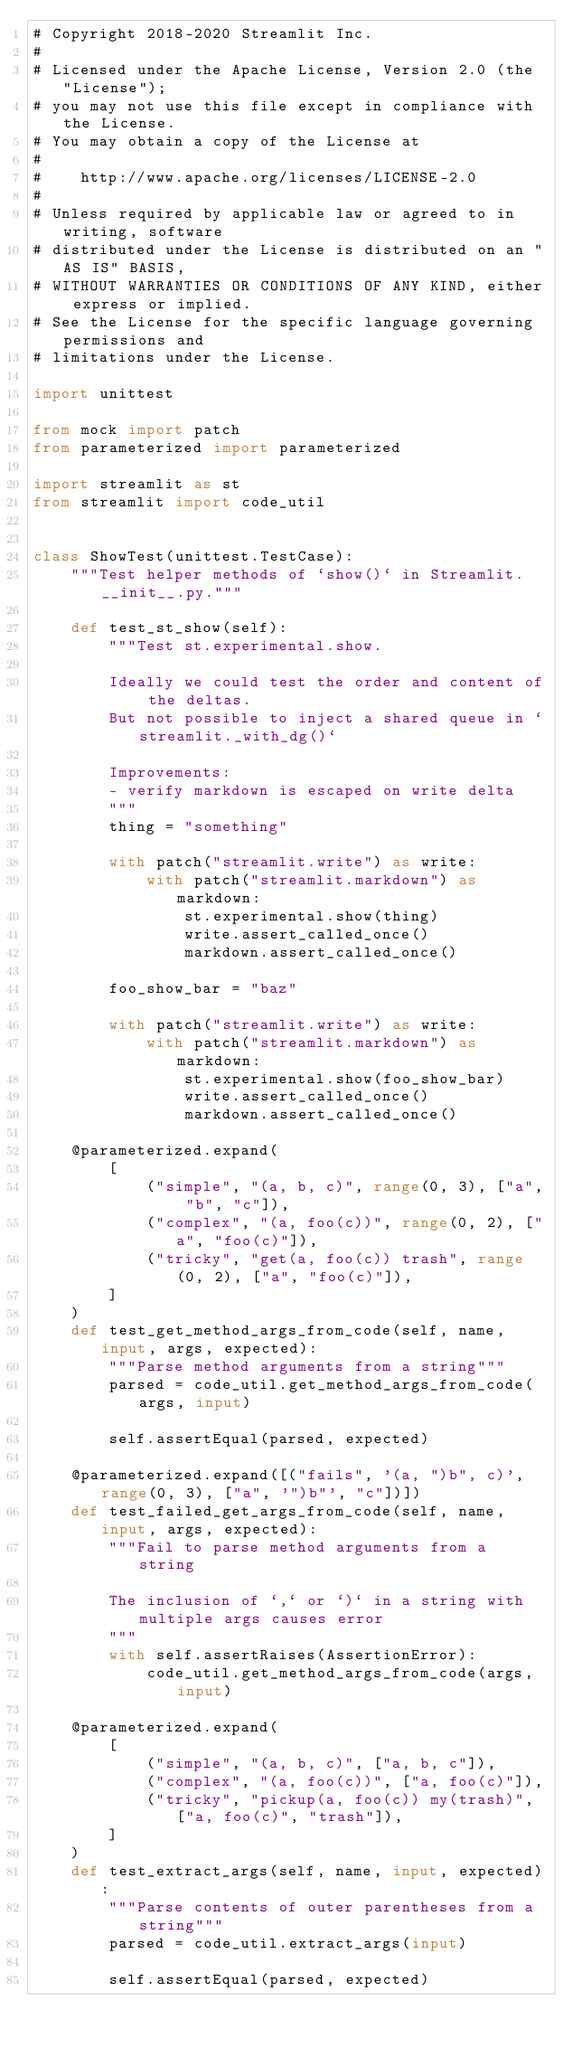Convert code to text. <code><loc_0><loc_0><loc_500><loc_500><_Python_># Copyright 2018-2020 Streamlit Inc.
#
# Licensed under the Apache License, Version 2.0 (the "License");
# you may not use this file except in compliance with the License.
# You may obtain a copy of the License at
#
#    http://www.apache.org/licenses/LICENSE-2.0
#
# Unless required by applicable law or agreed to in writing, software
# distributed under the License is distributed on an "AS IS" BASIS,
# WITHOUT WARRANTIES OR CONDITIONS OF ANY KIND, either express or implied.
# See the License for the specific language governing permissions and
# limitations under the License.

import unittest

from mock import patch
from parameterized import parameterized

import streamlit as st
from streamlit import code_util


class ShowTest(unittest.TestCase):
    """Test helper methods of `show()` in Streamlit.__init__.py."""

    def test_st_show(self):
        """Test st.experimental.show.

        Ideally we could test the order and content of the deltas.
        But not possible to inject a shared queue in `streamlit._with_dg()`

        Improvements:
        - verify markdown is escaped on write delta
        """
        thing = "something"

        with patch("streamlit.write") as write:
            with patch("streamlit.markdown") as markdown:
                st.experimental.show(thing)
                write.assert_called_once()
                markdown.assert_called_once()

        foo_show_bar = "baz"

        with patch("streamlit.write") as write:
            with patch("streamlit.markdown") as markdown:
                st.experimental.show(foo_show_bar)
                write.assert_called_once()
                markdown.assert_called_once()

    @parameterized.expand(
        [
            ("simple", "(a, b, c)", range(0, 3), ["a", "b", "c"]),
            ("complex", "(a, foo(c))", range(0, 2), ["a", "foo(c)"]),
            ("tricky", "get(a, foo(c)) trash", range(0, 2), ["a", "foo(c)"]),
        ]
    )
    def test_get_method_args_from_code(self, name, input, args, expected):
        """Parse method arguments from a string"""
        parsed = code_util.get_method_args_from_code(args, input)

        self.assertEqual(parsed, expected)

    @parameterized.expand([("fails", '(a, ")b", c)', range(0, 3), ["a", '")b"', "c"])])
    def test_failed_get_args_from_code(self, name, input, args, expected):
        """Fail to parse method arguments from a string

        The inclusion of `,` or `)` in a string with multiple args causes error
        """
        with self.assertRaises(AssertionError):
            code_util.get_method_args_from_code(args, input)

    @parameterized.expand(
        [
            ("simple", "(a, b, c)", ["a, b, c"]),
            ("complex", "(a, foo(c))", ["a, foo(c)"]),
            ("tricky", "pickup(a, foo(c)) my(trash)", ["a, foo(c)", "trash"]),
        ]
    )
    def test_extract_args(self, name, input, expected):
        """Parse contents of outer parentheses from a string"""
        parsed = code_util.extract_args(input)

        self.assertEqual(parsed, expected)
</code> 